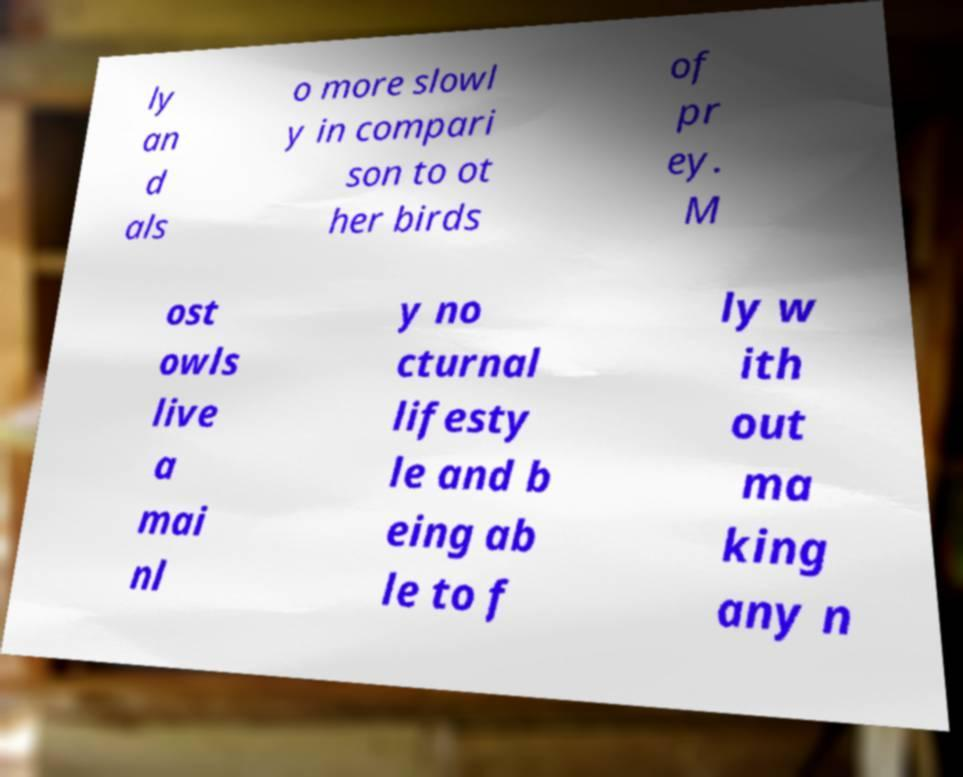Could you assist in decoding the text presented in this image and type it out clearly? ly an d als o more slowl y in compari son to ot her birds of pr ey. M ost owls live a mai nl y no cturnal lifesty le and b eing ab le to f ly w ith out ma king any n 